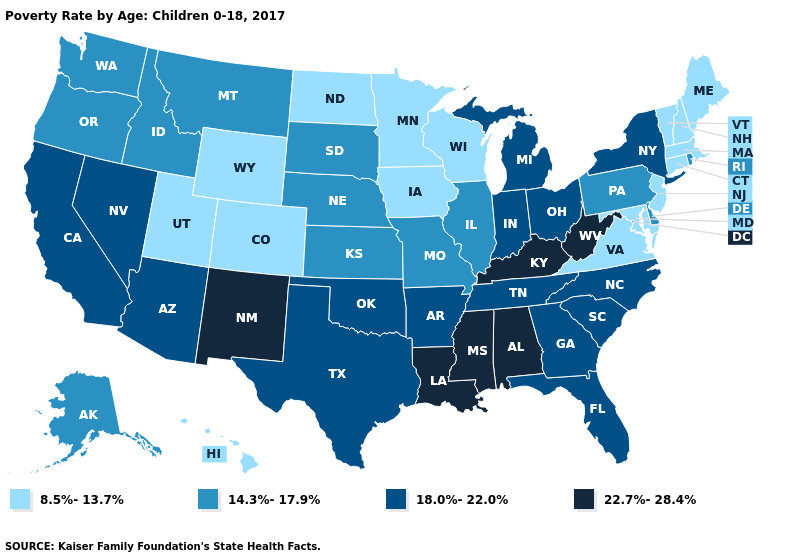What is the highest value in states that border Vermont?
Be succinct. 18.0%-22.0%. What is the lowest value in states that border Wisconsin?
Concise answer only. 8.5%-13.7%. What is the lowest value in the MidWest?
Keep it brief. 8.5%-13.7%. What is the lowest value in states that border Pennsylvania?
Be succinct. 8.5%-13.7%. Which states have the lowest value in the USA?
Short answer required. Colorado, Connecticut, Hawaii, Iowa, Maine, Maryland, Massachusetts, Minnesota, New Hampshire, New Jersey, North Dakota, Utah, Vermont, Virginia, Wisconsin, Wyoming. What is the value of Tennessee?
Be succinct. 18.0%-22.0%. What is the value of Nebraska?
Concise answer only. 14.3%-17.9%. What is the highest value in the USA?
Keep it brief. 22.7%-28.4%. Among the states that border Nevada , does California have the highest value?
Answer briefly. Yes. Name the states that have a value in the range 22.7%-28.4%?
Keep it brief. Alabama, Kentucky, Louisiana, Mississippi, New Mexico, West Virginia. What is the lowest value in the USA?
Answer briefly. 8.5%-13.7%. Among the states that border North Dakota , which have the lowest value?
Write a very short answer. Minnesota. Name the states that have a value in the range 14.3%-17.9%?
Short answer required. Alaska, Delaware, Idaho, Illinois, Kansas, Missouri, Montana, Nebraska, Oregon, Pennsylvania, Rhode Island, South Dakota, Washington. What is the lowest value in states that border Minnesota?
Be succinct. 8.5%-13.7%. Name the states that have a value in the range 22.7%-28.4%?
Be succinct. Alabama, Kentucky, Louisiana, Mississippi, New Mexico, West Virginia. 